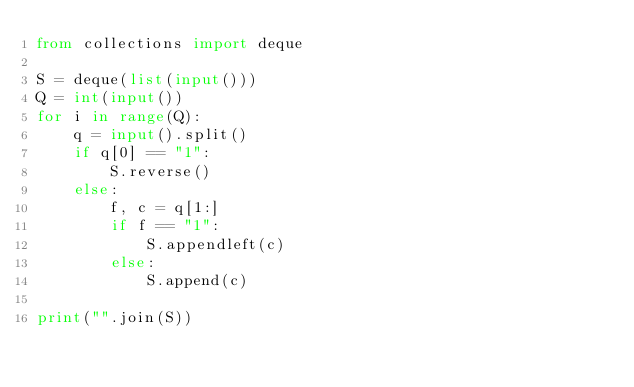<code> <loc_0><loc_0><loc_500><loc_500><_Python_>from collections import deque

S = deque(list(input()))
Q = int(input())
for i in range(Q):
    q = input().split()
    if q[0] == "1":
        S.reverse()
    else:
        f, c = q[1:]
        if f == "1":
            S.appendleft(c)
        else:
            S.append(c)

print("".join(S))</code> 